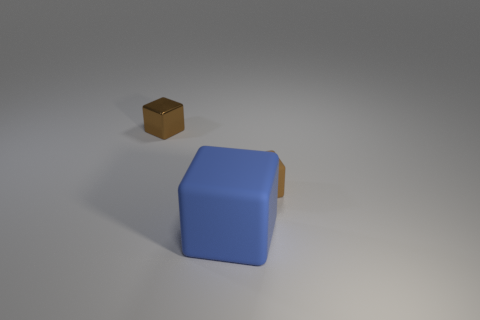There is a block on the right side of the blue cube; is it the same color as the tiny metallic object?
Your answer should be very brief. Yes. There is a thing that is behind the tiny brown matte cube; are there any blocks to the right of it?
Ensure brevity in your answer.  Yes. There is another brown thing that is the same shape as the small brown rubber thing; what material is it?
Keep it short and to the point. Metal. Is the number of big blue things greater than the number of green metal objects?
Give a very brief answer. Yes. There is a tiny rubber thing; is it the same color as the small block that is on the left side of the brown matte object?
Your answer should be compact. Yes. There is a cube that is left of the brown matte cube and behind the large rubber cube; what is its color?
Provide a short and direct response. Brown. What number of other objects are there of the same material as the big thing?
Provide a succinct answer. 1. Is the number of large blocks less than the number of matte objects?
Your answer should be compact. Yes. Does the large thing have the same material as the tiny cube that is right of the big rubber block?
Keep it short and to the point. Yes. What shape is the brown object on the right side of the tiny metallic thing?
Ensure brevity in your answer.  Cube. 